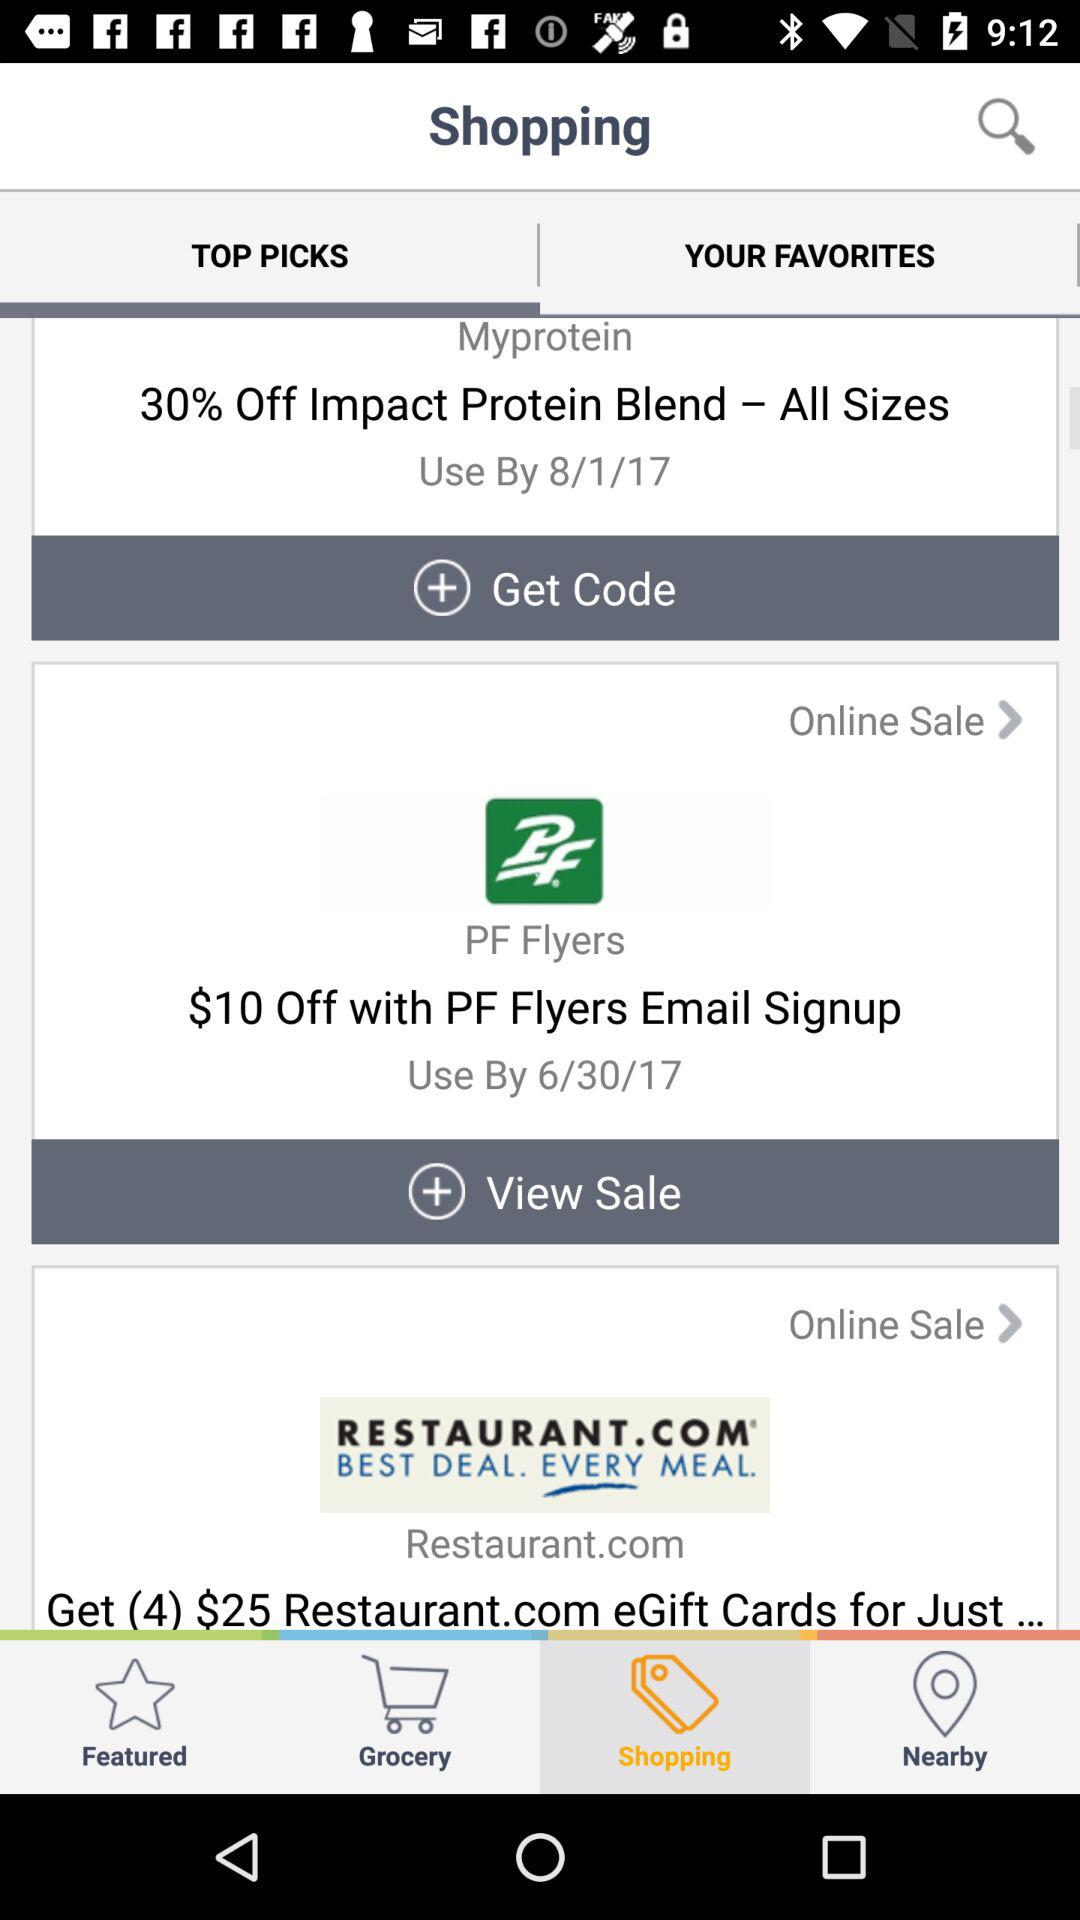Which tab is selected? The selected tabs are "TOP PICKS" and "Shopping". 